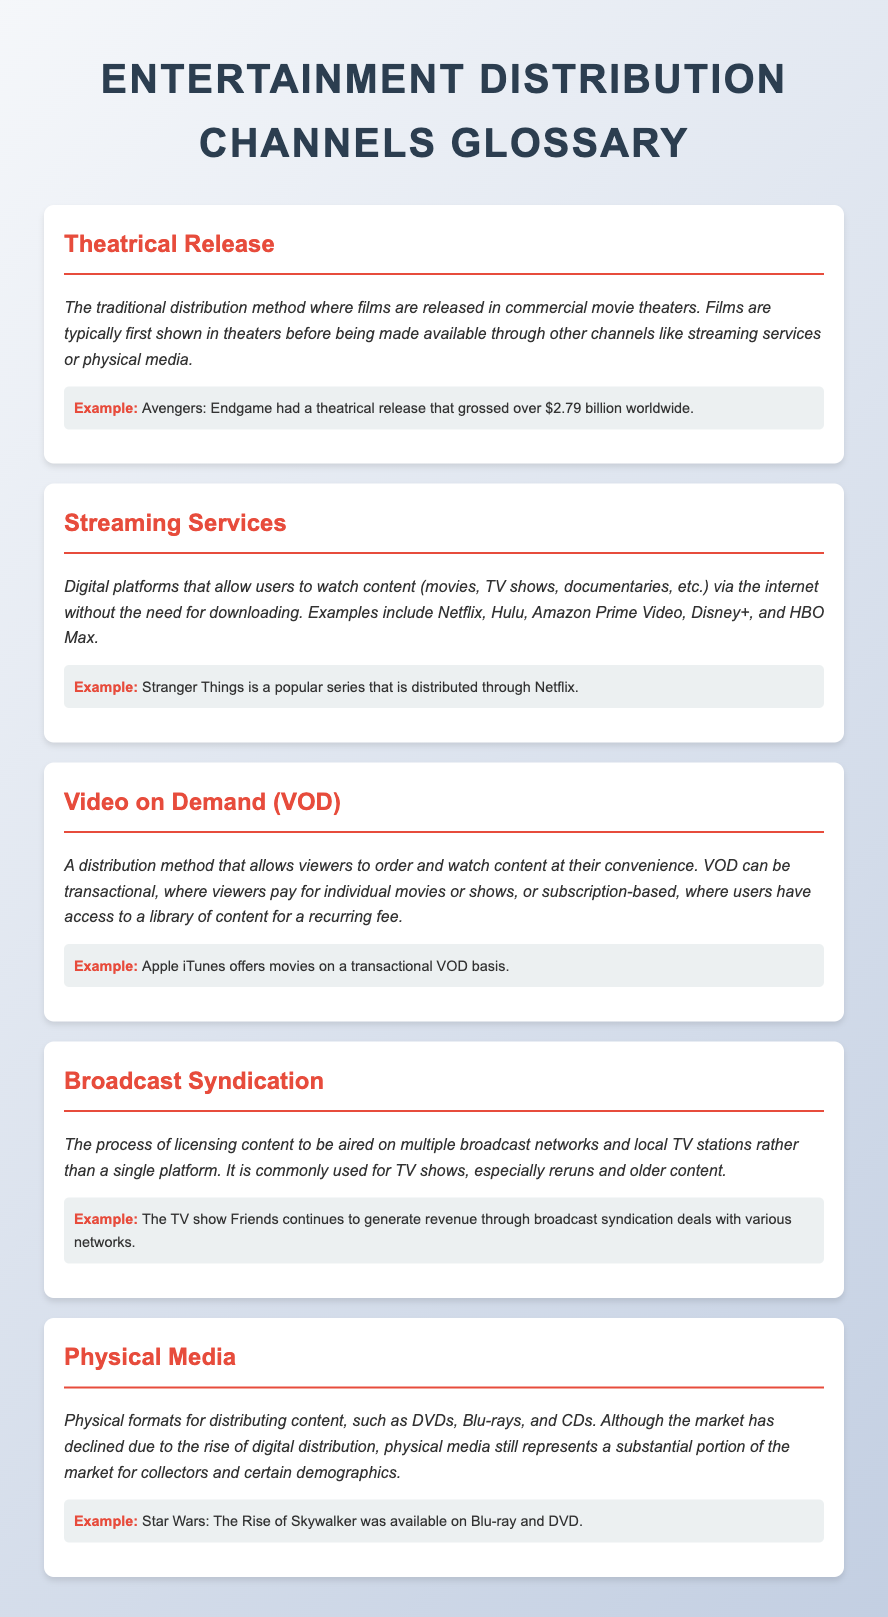what is a theatrical release? A theatrical release is the traditional distribution method where films are released in commercial movie theaters.
Answer: theatrical release what is an example of a streaming service? An example of a streaming service mentioned in the document is Netflix.
Answer: Netflix what does VOD stand for? VOD stands for Video on Demand.
Answer: Video on Demand how much did Avengers: Endgame gross worldwide? Avengers: Endgame grossed over $2.79 billion worldwide.
Answer: over $2.79 billion what is the primary use of broadcast syndication? Broadcast syndication is primarily used for licensing content to be aired on multiple broadcast networks and local TV stations.
Answer: licensing content what media formats are included in physical media? Physical media includes formats such as DVDs, Blu-rays, and CDs.
Answer: DVDs, Blu-rays, and CDs how does VOD allow viewers to access content? VOD allows viewers to order and watch content at their convenience.
Answer: at their convenience which TV show continues to generate revenue through syndication deals? The TV show that continues to generate revenue through syndication deals is Friends.
Answer: Friends 